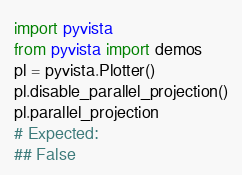<code> <loc_0><loc_0><loc_500><loc_500><_Python_>import pyvista
from pyvista import demos
pl = pyvista.Plotter()
pl.disable_parallel_projection()
pl.parallel_projection
# Expected:
## False
</code> 